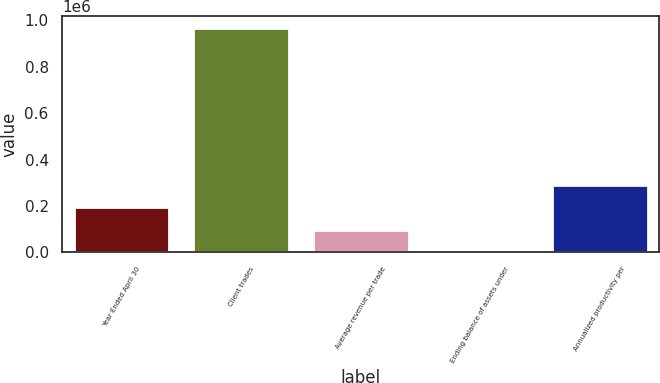Convert chart. <chart><loc_0><loc_0><loc_500><loc_500><bar_chart><fcel>Year Ended April 30<fcel>Client trades<fcel>Average revenue per trade<fcel>Ending balance of assets under<fcel>Annualized productivity per<nl><fcel>193898<fcel>969364<fcel>96965.3<fcel>32.1<fcel>290832<nl></chart> 